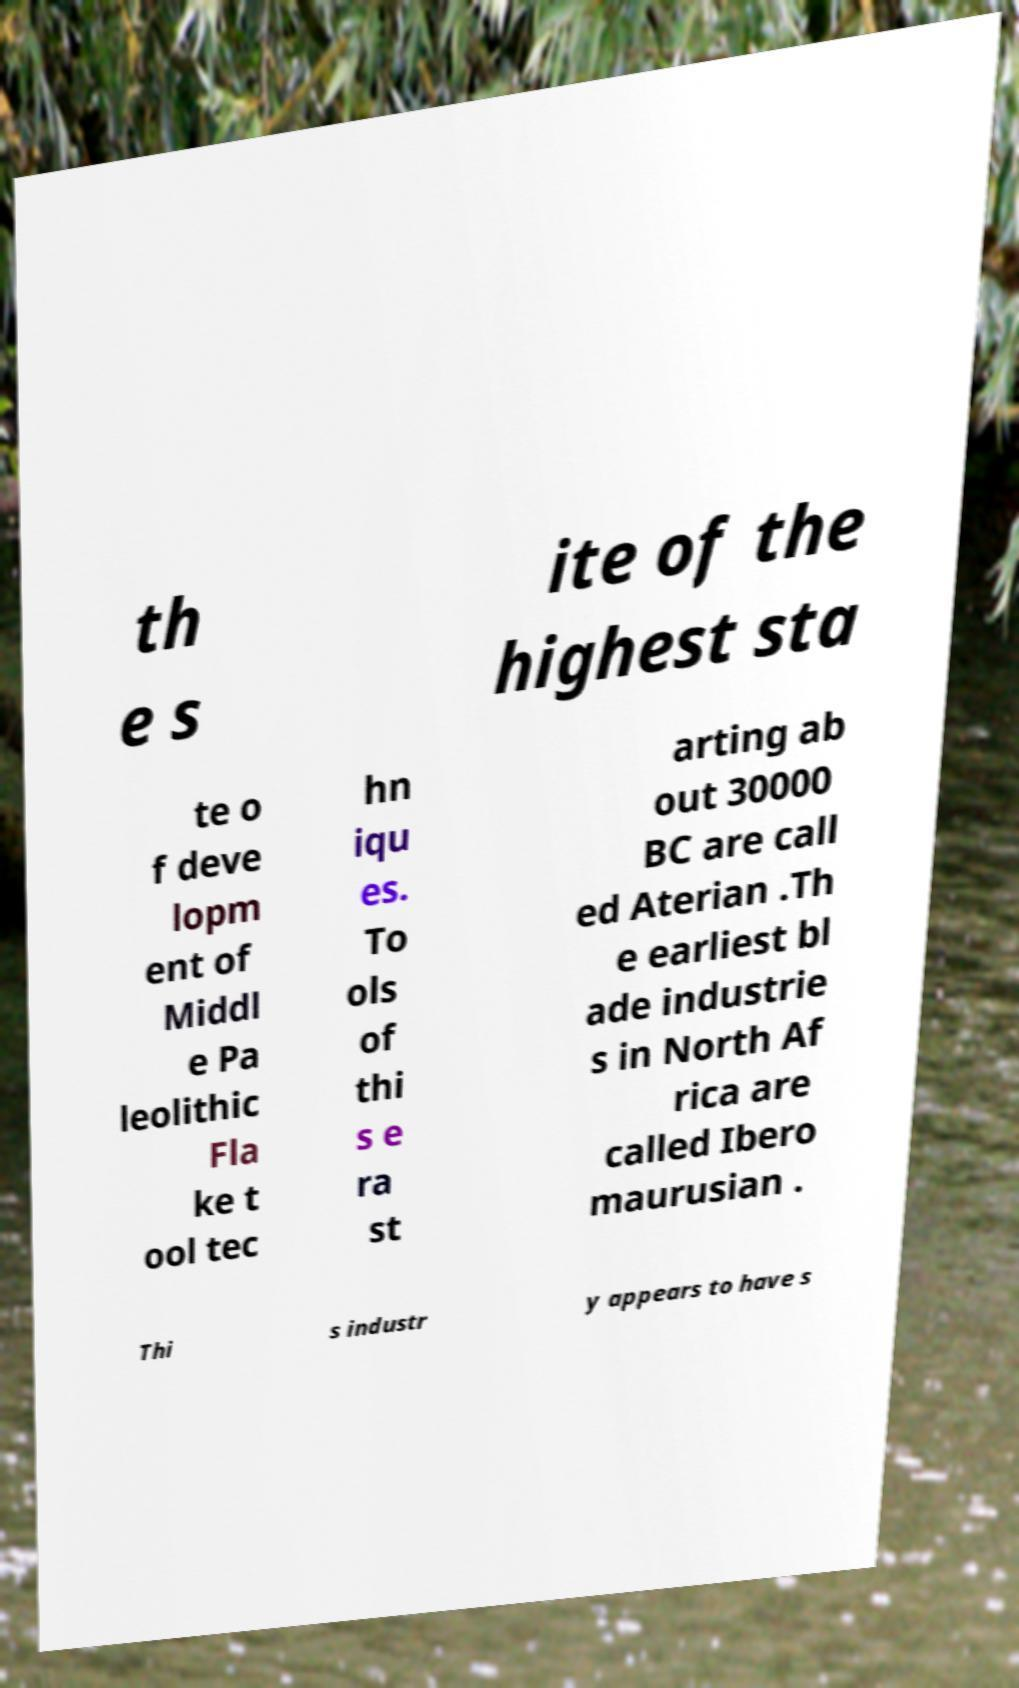For documentation purposes, I need the text within this image transcribed. Could you provide that? th e s ite of the highest sta te o f deve lopm ent of Middl e Pa leolithic Fla ke t ool tec hn iqu es. To ols of thi s e ra st arting ab out 30000 BC are call ed Aterian .Th e earliest bl ade industrie s in North Af rica are called Ibero maurusian . Thi s industr y appears to have s 